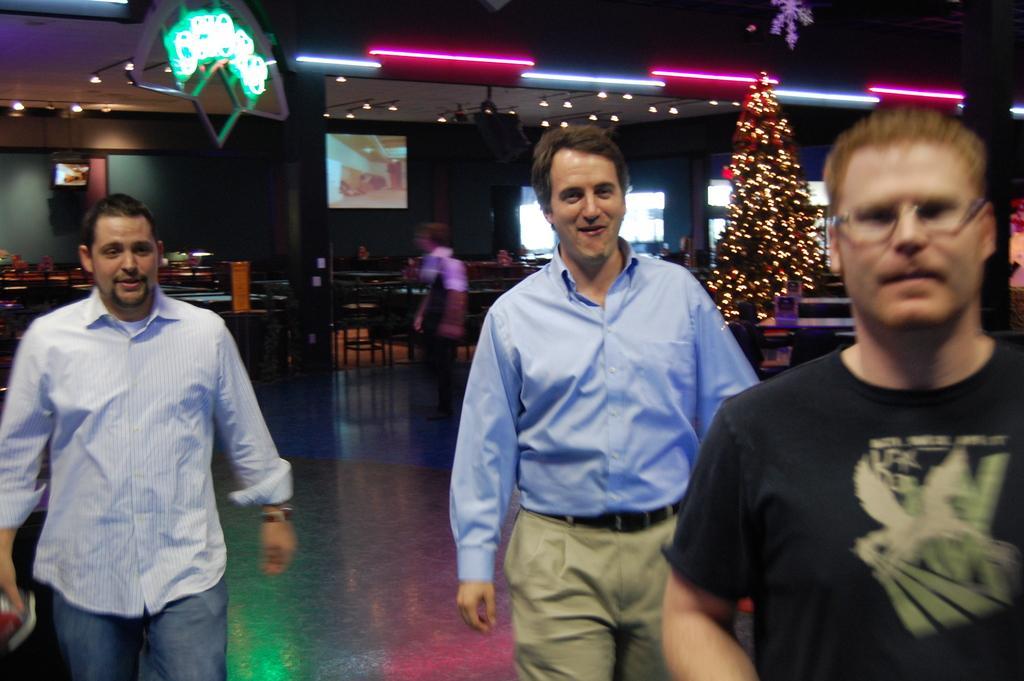Describe this image in one or two sentences. There are three men standing at the bottom of this image. We can see chairs, tables and a Christmas tree in the background. There are lights and screens present at the top of this image. 